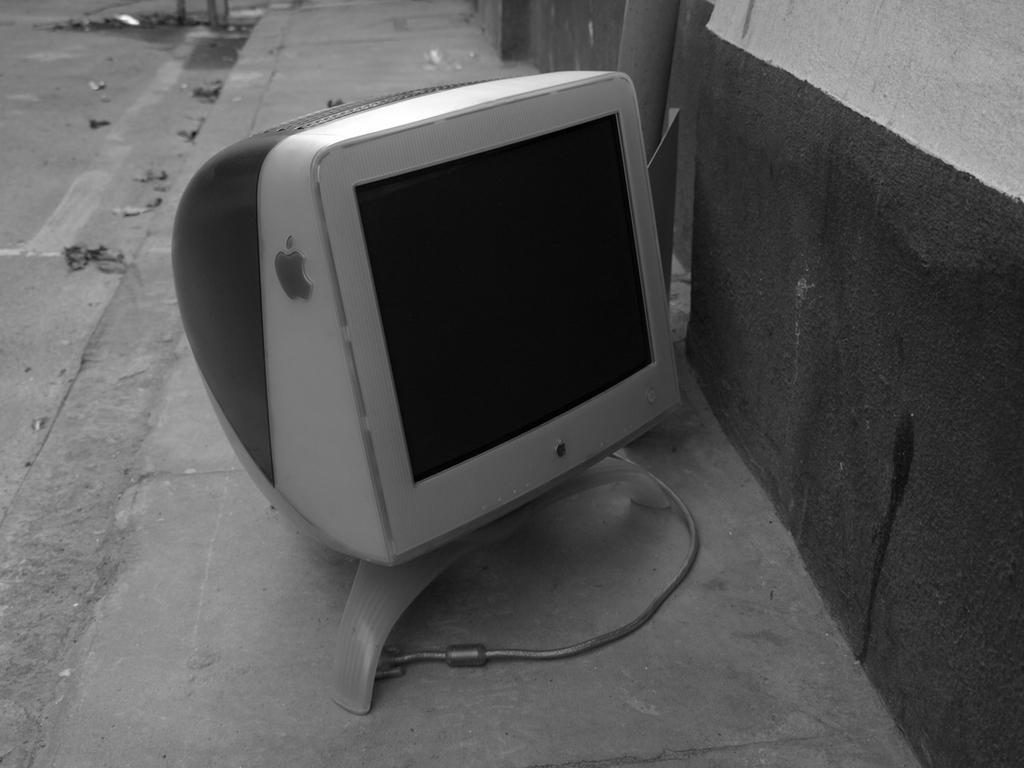Describe this image in one or two sentences. In this image there is a Macintosh monitor on the surface of the ground. 